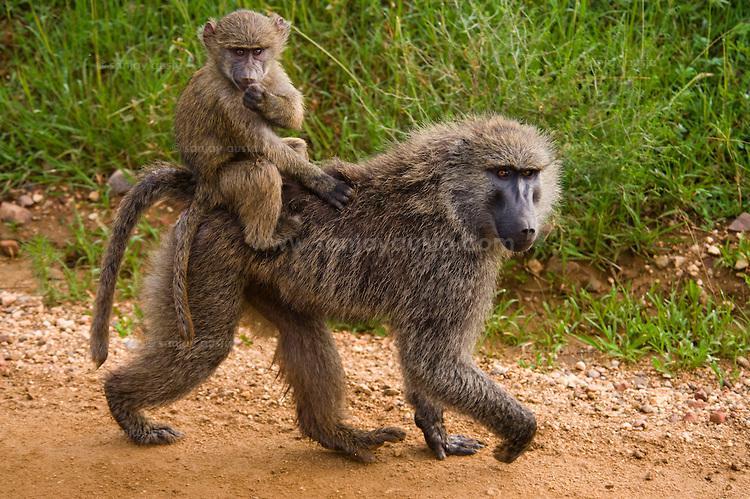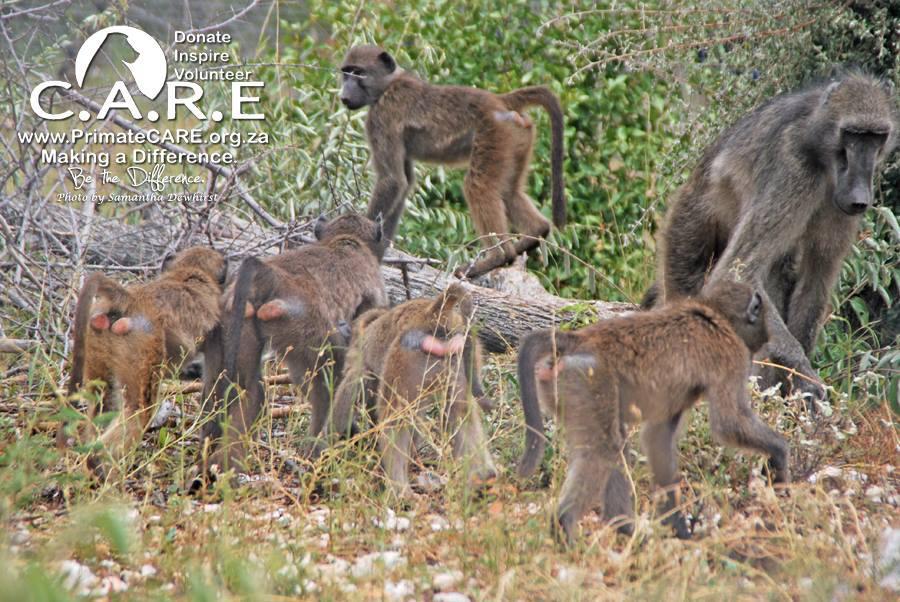The first image is the image on the left, the second image is the image on the right. Assess this claim about the two images: "No more than 2 baboons in either picture.". Correct or not? Answer yes or no. No. 